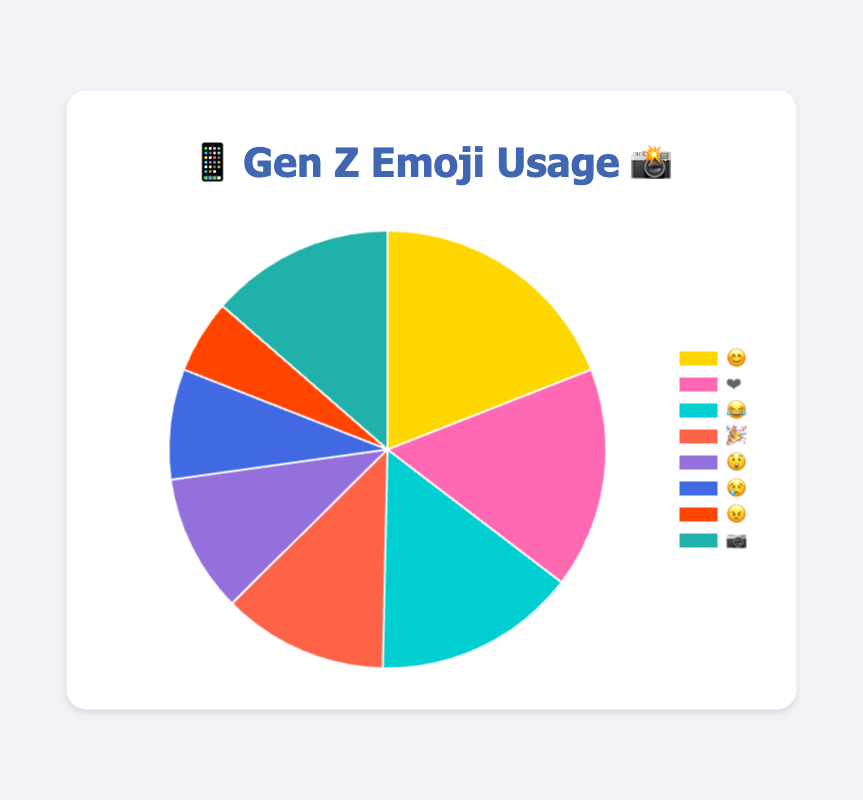Which emoji category is the most frequently used? The figure shows a pie chart with the emoji usage frequencies. The largest segment of the pie chart represents the most frequently used emoji. In this case, the smiley face, 😊, in the Happy category has the highest frequency.
Answer: Happy 😊 How many emojis are in the "Excited" category? In the pie chart, find the segment labeled with the "Excited" emoji (🎉). The frequency of this emoji is shown as 18.
Answer: 18 Which category has the fewest emojis used, and what is its frequency? The smallest segment on the pie chart corresponds to the least frequently used emoji. The segment labeled with the angry face 😠 represents the Angry category, which has a frequency of 8.
Answer: Angry 😠, 8 What is the total number of emojis used in the "Happy" and "Love" categories combined? Look at the frequencies of the "Happy" (😊, 28) and "Love" (❤️, 24) categories. Add them together: 28 + 24 = 52
Answer: 52 By how much does the "Laughing" category exceed the "Sad" category? Find the frequencies for "Laughing" (😂, 22) and "Sad" (😢, 12). Subtract the Sad frequency from the Laughing frequency: 22 - 12 = 10
Answer: 10 Which categories have emoji usage between 15 and 25, inclusive? Identify the segments whose frequencies fall within the range 15 to 25. These are "Love" (❤️, 24), "Laughing" (😂, 22), "Surprised" (😲, 15), and "Camera" (📷, 20).
Answer: Love ❤️, Laughing 😂, Surprised 😲, Camera 📷 How does the frequency of "Camera" emojis compare to "Excited" emojis? Check the frequencies for "Camera" (📷, 20) and "Excited" (🎉, 18). "Camera" emojis are more frequent by 2 emojis: 20 - 18 = 2
Answer: Camera 📷 is 2 more What's the sum of all emoji frequencies? Sum all the frequencies from the chart: 28 (Happy) + 24 (Love) + 22 (Laughing) + 18 (Excited) + 15 (Surprised) + 12 (Sad) + 8 (Angry) + 20 (Camera) = 147
Answer: 147 